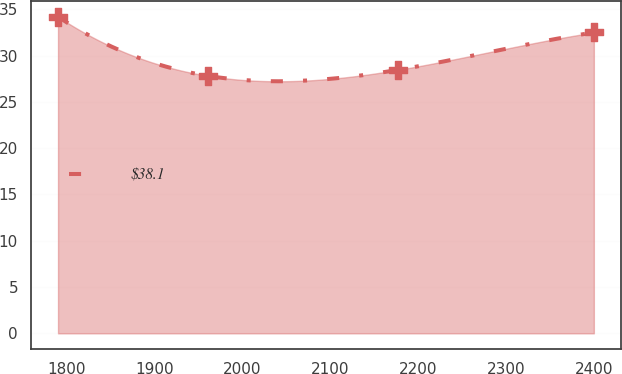Convert chart. <chart><loc_0><loc_0><loc_500><loc_500><line_chart><ecel><fcel>$38.1<nl><fcel>1790.34<fcel>34.19<nl><fcel>1960.63<fcel>27.81<nl><fcel>2176.94<fcel>28.45<nl><fcel>2399.97<fcel>32.49<nl></chart> 